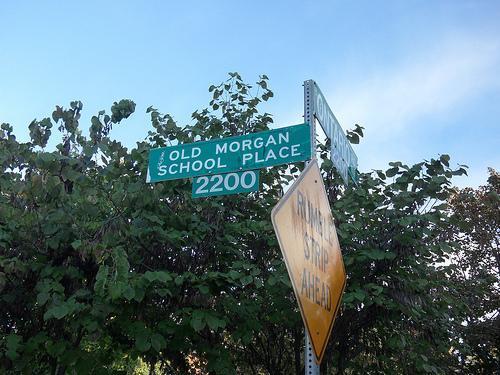How many yellow signs are in the photo?
Give a very brief answer. 1. How many signs are green?
Give a very brief answer. 2. 